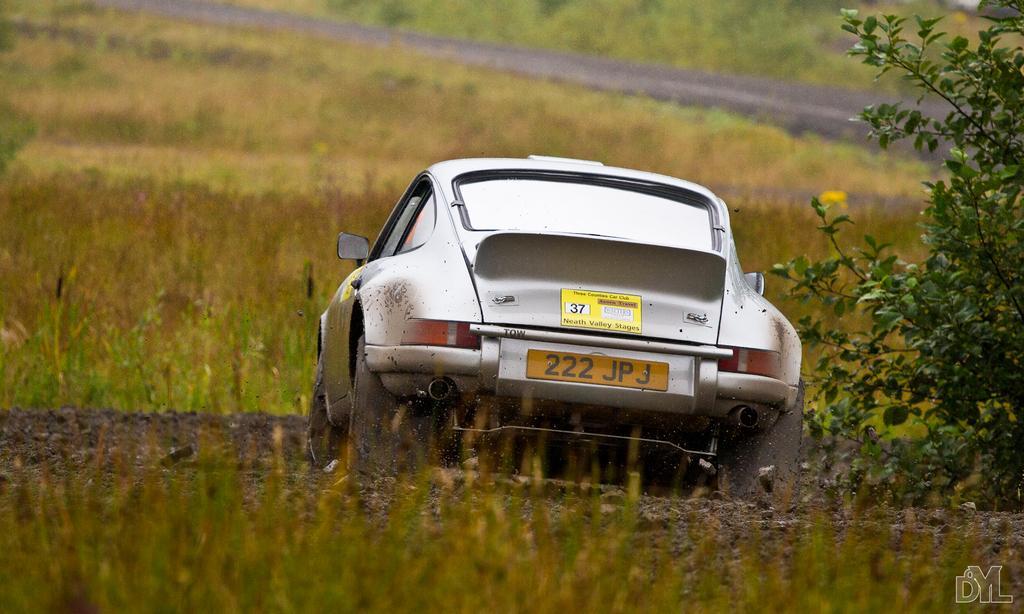How would you summarize this image in a sentence or two? In this image we can see a car which is of silver color moving on the grass, at the right side of the image there is plant and at the background of the image there is grass. 